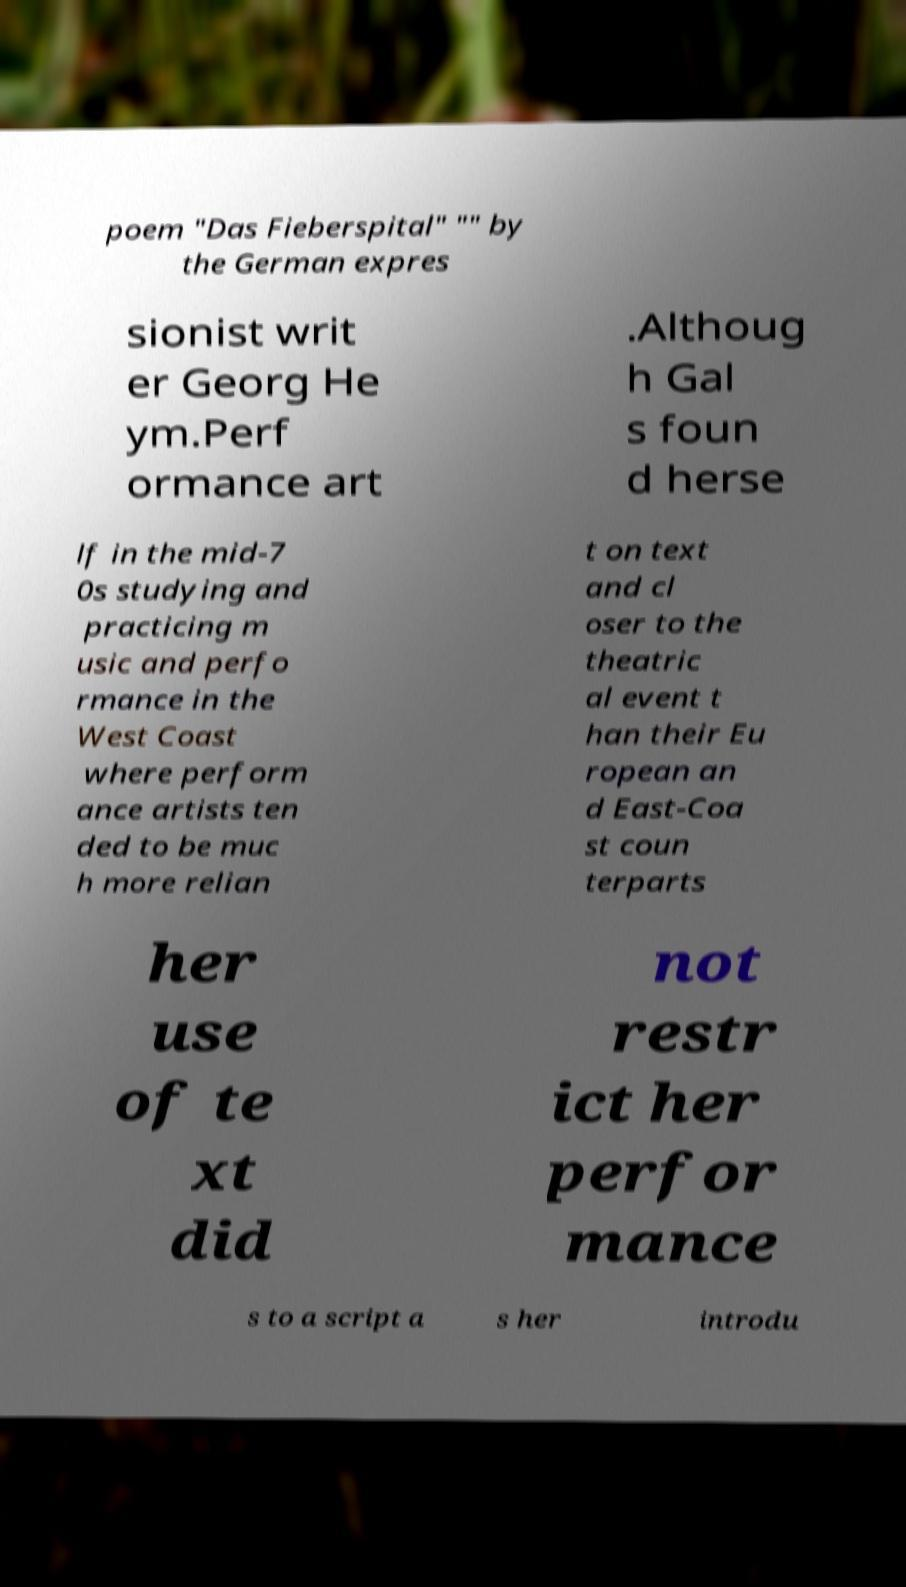Can you read and provide the text displayed in the image?This photo seems to have some interesting text. Can you extract and type it out for me? poem "Das Fieberspital" "" by the German expres sionist writ er Georg He ym.Perf ormance art .Althoug h Gal s foun d herse lf in the mid-7 0s studying and practicing m usic and perfo rmance in the West Coast where perform ance artists ten ded to be muc h more relian t on text and cl oser to the theatric al event t han their Eu ropean an d East-Coa st coun terparts her use of te xt did not restr ict her perfor mance s to a script a s her introdu 